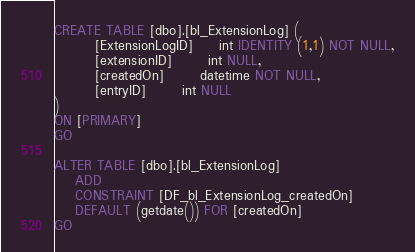Convert code to text. <code><loc_0><loc_0><loc_500><loc_500><_SQL_>CREATE TABLE [dbo].[bl_ExtensionLog] (
		[ExtensionLogID]     int IDENTITY (1,1) NOT NULL,
		[extensionID]       int NULL,
		[createdOn]       datetime NOT NULL,
		[entryID]       int NULL
)
ON [PRIMARY]
GO

ALTER TABLE [dbo].[bl_ExtensionLog]
	ADD
	CONSTRAINT [DF_bl_ExtensionLog_createdOn]
	DEFAULT (getdate()) FOR [createdOn]
GO
</code> 